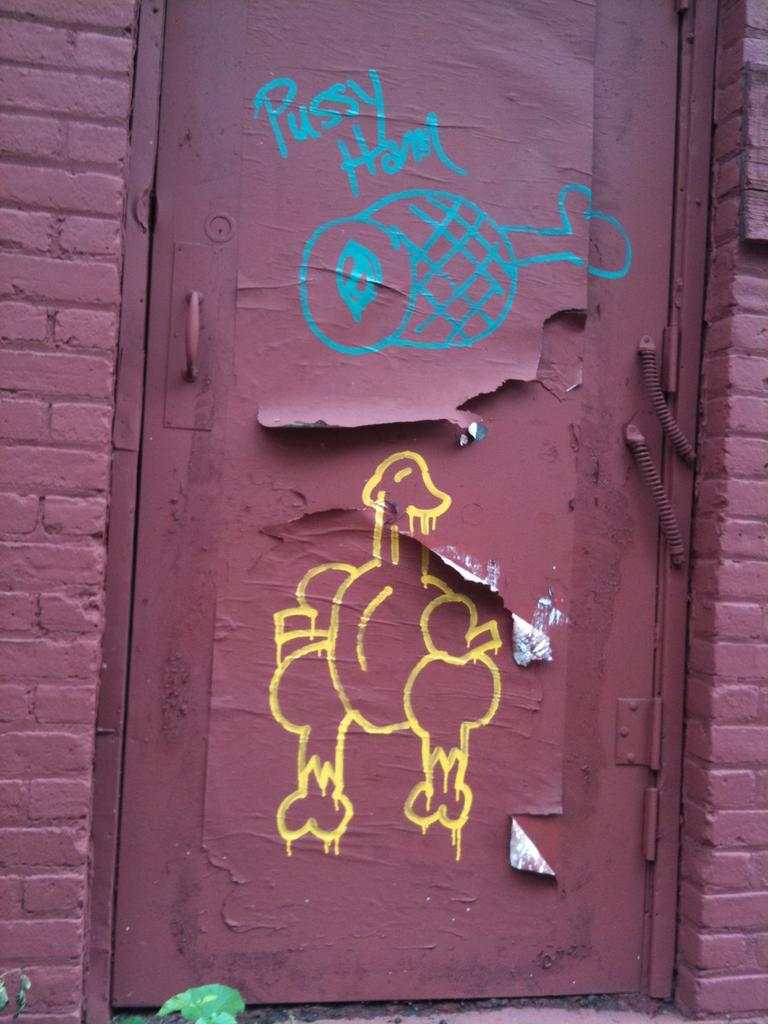How would you summarize this image in a sentence or two? In the image there is a door and around the door there are two walls. 